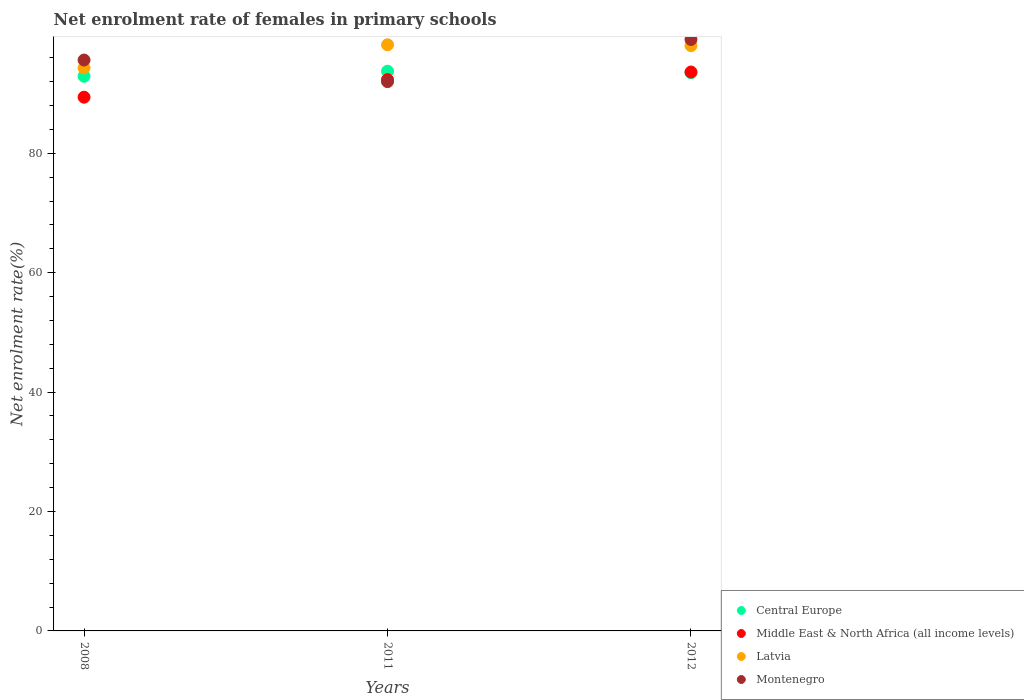Is the number of dotlines equal to the number of legend labels?
Provide a short and direct response. Yes. What is the net enrolment rate of females in primary schools in Middle East & North Africa (all income levels) in 2011?
Make the answer very short. 92.32. Across all years, what is the maximum net enrolment rate of females in primary schools in Latvia?
Your response must be concise. 98.16. Across all years, what is the minimum net enrolment rate of females in primary schools in Middle East & North Africa (all income levels)?
Provide a succinct answer. 89.39. In which year was the net enrolment rate of females in primary schools in Central Europe maximum?
Make the answer very short. 2011. In which year was the net enrolment rate of females in primary schools in Montenegro minimum?
Offer a terse response. 2011. What is the total net enrolment rate of females in primary schools in Middle East & North Africa (all income levels) in the graph?
Keep it short and to the point. 275.31. What is the difference between the net enrolment rate of females in primary schools in Montenegro in 2008 and that in 2012?
Your response must be concise. -3.45. What is the difference between the net enrolment rate of females in primary schools in Central Europe in 2012 and the net enrolment rate of females in primary schools in Latvia in 2008?
Provide a short and direct response. -0.82. What is the average net enrolment rate of females in primary schools in Central Europe per year?
Offer a very short reply. 93.37. In the year 2012, what is the difference between the net enrolment rate of females in primary schools in Montenegro and net enrolment rate of females in primary schools in Middle East & North Africa (all income levels)?
Keep it short and to the point. 5.45. In how many years, is the net enrolment rate of females in primary schools in Montenegro greater than 72 %?
Offer a terse response. 3. What is the ratio of the net enrolment rate of females in primary schools in Central Europe in 2011 to that in 2012?
Your answer should be very brief. 1. Is the net enrolment rate of females in primary schools in Montenegro in 2011 less than that in 2012?
Offer a very short reply. Yes. What is the difference between the highest and the second highest net enrolment rate of females in primary schools in Latvia?
Your answer should be very brief. 0.15. What is the difference between the highest and the lowest net enrolment rate of females in primary schools in Middle East & North Africa (all income levels)?
Your answer should be compact. 4.22. In how many years, is the net enrolment rate of females in primary schools in Central Europe greater than the average net enrolment rate of females in primary schools in Central Europe taken over all years?
Your answer should be compact. 2. Is the sum of the net enrolment rate of females in primary schools in Montenegro in 2008 and 2012 greater than the maximum net enrolment rate of females in primary schools in Latvia across all years?
Ensure brevity in your answer.  Yes. Is it the case that in every year, the sum of the net enrolment rate of females in primary schools in Middle East & North Africa (all income levels) and net enrolment rate of females in primary schools in Central Europe  is greater than the sum of net enrolment rate of females in primary schools in Montenegro and net enrolment rate of females in primary schools in Latvia?
Provide a succinct answer. No. Is it the case that in every year, the sum of the net enrolment rate of females in primary schools in Middle East & North Africa (all income levels) and net enrolment rate of females in primary schools in Central Europe  is greater than the net enrolment rate of females in primary schools in Latvia?
Keep it short and to the point. Yes. Does the net enrolment rate of females in primary schools in Central Europe monotonically increase over the years?
Your answer should be very brief. No. What is the difference between two consecutive major ticks on the Y-axis?
Provide a short and direct response. 20. Are the values on the major ticks of Y-axis written in scientific E-notation?
Offer a terse response. No. Does the graph contain any zero values?
Your answer should be very brief. No. Does the graph contain grids?
Make the answer very short. No. Where does the legend appear in the graph?
Keep it short and to the point. Bottom right. How many legend labels are there?
Offer a very short reply. 4. What is the title of the graph?
Offer a very short reply. Net enrolment rate of females in primary schools. What is the label or title of the X-axis?
Offer a terse response. Years. What is the label or title of the Y-axis?
Provide a short and direct response. Net enrolment rate(%). What is the Net enrolment rate(%) of Central Europe in 2008?
Make the answer very short. 92.89. What is the Net enrolment rate(%) of Middle East & North Africa (all income levels) in 2008?
Keep it short and to the point. 89.39. What is the Net enrolment rate(%) in Latvia in 2008?
Make the answer very short. 94.3. What is the Net enrolment rate(%) of Montenegro in 2008?
Your answer should be compact. 95.61. What is the Net enrolment rate(%) of Central Europe in 2011?
Offer a terse response. 93.74. What is the Net enrolment rate(%) in Middle East & North Africa (all income levels) in 2011?
Keep it short and to the point. 92.32. What is the Net enrolment rate(%) in Latvia in 2011?
Make the answer very short. 98.16. What is the Net enrolment rate(%) in Montenegro in 2011?
Offer a very short reply. 91.99. What is the Net enrolment rate(%) in Central Europe in 2012?
Offer a terse response. 93.47. What is the Net enrolment rate(%) in Middle East & North Africa (all income levels) in 2012?
Ensure brevity in your answer.  93.61. What is the Net enrolment rate(%) in Latvia in 2012?
Ensure brevity in your answer.  98.01. What is the Net enrolment rate(%) in Montenegro in 2012?
Keep it short and to the point. 99.05. Across all years, what is the maximum Net enrolment rate(%) of Central Europe?
Offer a very short reply. 93.74. Across all years, what is the maximum Net enrolment rate(%) in Middle East & North Africa (all income levels)?
Your answer should be compact. 93.61. Across all years, what is the maximum Net enrolment rate(%) of Latvia?
Provide a succinct answer. 98.16. Across all years, what is the maximum Net enrolment rate(%) of Montenegro?
Your response must be concise. 99.05. Across all years, what is the minimum Net enrolment rate(%) in Central Europe?
Give a very brief answer. 92.89. Across all years, what is the minimum Net enrolment rate(%) in Middle East & North Africa (all income levels)?
Provide a succinct answer. 89.39. Across all years, what is the minimum Net enrolment rate(%) in Latvia?
Your response must be concise. 94.3. Across all years, what is the minimum Net enrolment rate(%) in Montenegro?
Ensure brevity in your answer.  91.99. What is the total Net enrolment rate(%) of Central Europe in the graph?
Provide a short and direct response. 280.1. What is the total Net enrolment rate(%) of Middle East & North Africa (all income levels) in the graph?
Provide a short and direct response. 275.31. What is the total Net enrolment rate(%) in Latvia in the graph?
Offer a very short reply. 290.47. What is the total Net enrolment rate(%) in Montenegro in the graph?
Offer a terse response. 286.65. What is the difference between the Net enrolment rate(%) of Central Europe in 2008 and that in 2011?
Give a very brief answer. -0.84. What is the difference between the Net enrolment rate(%) in Middle East & North Africa (all income levels) in 2008 and that in 2011?
Make the answer very short. -2.94. What is the difference between the Net enrolment rate(%) in Latvia in 2008 and that in 2011?
Provide a short and direct response. -3.86. What is the difference between the Net enrolment rate(%) in Montenegro in 2008 and that in 2011?
Your answer should be very brief. 3.62. What is the difference between the Net enrolment rate(%) in Central Europe in 2008 and that in 2012?
Provide a short and direct response. -0.58. What is the difference between the Net enrolment rate(%) of Middle East & North Africa (all income levels) in 2008 and that in 2012?
Ensure brevity in your answer.  -4.22. What is the difference between the Net enrolment rate(%) of Latvia in 2008 and that in 2012?
Make the answer very short. -3.72. What is the difference between the Net enrolment rate(%) of Montenegro in 2008 and that in 2012?
Give a very brief answer. -3.45. What is the difference between the Net enrolment rate(%) in Central Europe in 2011 and that in 2012?
Provide a succinct answer. 0.27. What is the difference between the Net enrolment rate(%) of Middle East & North Africa (all income levels) in 2011 and that in 2012?
Your response must be concise. -1.28. What is the difference between the Net enrolment rate(%) in Latvia in 2011 and that in 2012?
Your answer should be compact. 0.15. What is the difference between the Net enrolment rate(%) in Montenegro in 2011 and that in 2012?
Your answer should be compact. -7.06. What is the difference between the Net enrolment rate(%) in Central Europe in 2008 and the Net enrolment rate(%) in Middle East & North Africa (all income levels) in 2011?
Make the answer very short. 0.57. What is the difference between the Net enrolment rate(%) of Central Europe in 2008 and the Net enrolment rate(%) of Latvia in 2011?
Make the answer very short. -5.27. What is the difference between the Net enrolment rate(%) in Central Europe in 2008 and the Net enrolment rate(%) in Montenegro in 2011?
Your answer should be very brief. 0.9. What is the difference between the Net enrolment rate(%) in Middle East & North Africa (all income levels) in 2008 and the Net enrolment rate(%) in Latvia in 2011?
Your answer should be compact. -8.78. What is the difference between the Net enrolment rate(%) of Middle East & North Africa (all income levels) in 2008 and the Net enrolment rate(%) of Montenegro in 2011?
Ensure brevity in your answer.  -2.61. What is the difference between the Net enrolment rate(%) of Latvia in 2008 and the Net enrolment rate(%) of Montenegro in 2011?
Ensure brevity in your answer.  2.31. What is the difference between the Net enrolment rate(%) of Central Europe in 2008 and the Net enrolment rate(%) of Middle East & North Africa (all income levels) in 2012?
Ensure brevity in your answer.  -0.71. What is the difference between the Net enrolment rate(%) in Central Europe in 2008 and the Net enrolment rate(%) in Latvia in 2012?
Give a very brief answer. -5.12. What is the difference between the Net enrolment rate(%) in Central Europe in 2008 and the Net enrolment rate(%) in Montenegro in 2012?
Offer a very short reply. -6.16. What is the difference between the Net enrolment rate(%) of Middle East & North Africa (all income levels) in 2008 and the Net enrolment rate(%) of Latvia in 2012?
Provide a short and direct response. -8.63. What is the difference between the Net enrolment rate(%) in Middle East & North Africa (all income levels) in 2008 and the Net enrolment rate(%) in Montenegro in 2012?
Your answer should be very brief. -9.67. What is the difference between the Net enrolment rate(%) in Latvia in 2008 and the Net enrolment rate(%) in Montenegro in 2012?
Provide a short and direct response. -4.76. What is the difference between the Net enrolment rate(%) of Central Europe in 2011 and the Net enrolment rate(%) of Middle East & North Africa (all income levels) in 2012?
Your response must be concise. 0.13. What is the difference between the Net enrolment rate(%) in Central Europe in 2011 and the Net enrolment rate(%) in Latvia in 2012?
Ensure brevity in your answer.  -4.28. What is the difference between the Net enrolment rate(%) of Central Europe in 2011 and the Net enrolment rate(%) of Montenegro in 2012?
Make the answer very short. -5.32. What is the difference between the Net enrolment rate(%) of Middle East & North Africa (all income levels) in 2011 and the Net enrolment rate(%) of Latvia in 2012?
Offer a terse response. -5.69. What is the difference between the Net enrolment rate(%) in Middle East & North Africa (all income levels) in 2011 and the Net enrolment rate(%) in Montenegro in 2012?
Make the answer very short. -6.73. What is the difference between the Net enrolment rate(%) of Latvia in 2011 and the Net enrolment rate(%) of Montenegro in 2012?
Your response must be concise. -0.89. What is the average Net enrolment rate(%) of Central Europe per year?
Provide a short and direct response. 93.37. What is the average Net enrolment rate(%) in Middle East & North Africa (all income levels) per year?
Offer a very short reply. 91.77. What is the average Net enrolment rate(%) in Latvia per year?
Give a very brief answer. 96.82. What is the average Net enrolment rate(%) in Montenegro per year?
Provide a succinct answer. 95.55. In the year 2008, what is the difference between the Net enrolment rate(%) of Central Europe and Net enrolment rate(%) of Middle East & North Africa (all income levels)?
Your answer should be very brief. 3.51. In the year 2008, what is the difference between the Net enrolment rate(%) in Central Europe and Net enrolment rate(%) in Latvia?
Provide a succinct answer. -1.4. In the year 2008, what is the difference between the Net enrolment rate(%) of Central Europe and Net enrolment rate(%) of Montenegro?
Provide a succinct answer. -2.71. In the year 2008, what is the difference between the Net enrolment rate(%) in Middle East & North Africa (all income levels) and Net enrolment rate(%) in Latvia?
Ensure brevity in your answer.  -4.91. In the year 2008, what is the difference between the Net enrolment rate(%) in Middle East & North Africa (all income levels) and Net enrolment rate(%) in Montenegro?
Provide a succinct answer. -6.22. In the year 2008, what is the difference between the Net enrolment rate(%) of Latvia and Net enrolment rate(%) of Montenegro?
Your response must be concise. -1.31. In the year 2011, what is the difference between the Net enrolment rate(%) of Central Europe and Net enrolment rate(%) of Middle East & North Africa (all income levels)?
Make the answer very short. 1.42. In the year 2011, what is the difference between the Net enrolment rate(%) in Central Europe and Net enrolment rate(%) in Latvia?
Offer a very short reply. -4.42. In the year 2011, what is the difference between the Net enrolment rate(%) of Central Europe and Net enrolment rate(%) of Montenegro?
Your response must be concise. 1.75. In the year 2011, what is the difference between the Net enrolment rate(%) of Middle East & North Africa (all income levels) and Net enrolment rate(%) of Latvia?
Offer a terse response. -5.84. In the year 2011, what is the difference between the Net enrolment rate(%) in Middle East & North Africa (all income levels) and Net enrolment rate(%) in Montenegro?
Provide a short and direct response. 0.33. In the year 2011, what is the difference between the Net enrolment rate(%) of Latvia and Net enrolment rate(%) of Montenegro?
Ensure brevity in your answer.  6.17. In the year 2012, what is the difference between the Net enrolment rate(%) in Central Europe and Net enrolment rate(%) in Middle East & North Africa (all income levels)?
Provide a succinct answer. -0.13. In the year 2012, what is the difference between the Net enrolment rate(%) in Central Europe and Net enrolment rate(%) in Latvia?
Your response must be concise. -4.54. In the year 2012, what is the difference between the Net enrolment rate(%) of Central Europe and Net enrolment rate(%) of Montenegro?
Your answer should be very brief. -5.58. In the year 2012, what is the difference between the Net enrolment rate(%) of Middle East & North Africa (all income levels) and Net enrolment rate(%) of Latvia?
Make the answer very short. -4.41. In the year 2012, what is the difference between the Net enrolment rate(%) of Middle East & North Africa (all income levels) and Net enrolment rate(%) of Montenegro?
Your answer should be very brief. -5.45. In the year 2012, what is the difference between the Net enrolment rate(%) of Latvia and Net enrolment rate(%) of Montenegro?
Provide a succinct answer. -1.04. What is the ratio of the Net enrolment rate(%) in Middle East & North Africa (all income levels) in 2008 to that in 2011?
Ensure brevity in your answer.  0.97. What is the ratio of the Net enrolment rate(%) of Latvia in 2008 to that in 2011?
Your response must be concise. 0.96. What is the ratio of the Net enrolment rate(%) of Montenegro in 2008 to that in 2011?
Keep it short and to the point. 1.04. What is the ratio of the Net enrolment rate(%) in Central Europe in 2008 to that in 2012?
Provide a succinct answer. 0.99. What is the ratio of the Net enrolment rate(%) of Middle East & North Africa (all income levels) in 2008 to that in 2012?
Your answer should be very brief. 0.95. What is the ratio of the Net enrolment rate(%) in Latvia in 2008 to that in 2012?
Provide a short and direct response. 0.96. What is the ratio of the Net enrolment rate(%) of Montenegro in 2008 to that in 2012?
Make the answer very short. 0.97. What is the ratio of the Net enrolment rate(%) of Middle East & North Africa (all income levels) in 2011 to that in 2012?
Make the answer very short. 0.99. What is the ratio of the Net enrolment rate(%) of Montenegro in 2011 to that in 2012?
Keep it short and to the point. 0.93. What is the difference between the highest and the second highest Net enrolment rate(%) of Central Europe?
Offer a terse response. 0.27. What is the difference between the highest and the second highest Net enrolment rate(%) in Middle East & North Africa (all income levels)?
Offer a very short reply. 1.28. What is the difference between the highest and the second highest Net enrolment rate(%) of Latvia?
Your response must be concise. 0.15. What is the difference between the highest and the second highest Net enrolment rate(%) of Montenegro?
Your response must be concise. 3.45. What is the difference between the highest and the lowest Net enrolment rate(%) in Central Europe?
Your answer should be very brief. 0.84. What is the difference between the highest and the lowest Net enrolment rate(%) of Middle East & North Africa (all income levels)?
Your response must be concise. 4.22. What is the difference between the highest and the lowest Net enrolment rate(%) in Latvia?
Offer a very short reply. 3.86. What is the difference between the highest and the lowest Net enrolment rate(%) of Montenegro?
Your response must be concise. 7.06. 